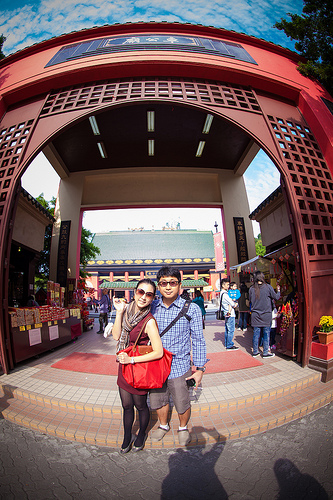<image>
Can you confirm if the woman is to the right of the man? Yes. From this viewpoint, the woman is positioned to the right side relative to the man. Is the woman next to the man? Yes. The woman is positioned adjacent to the man, located nearby in the same general area. 